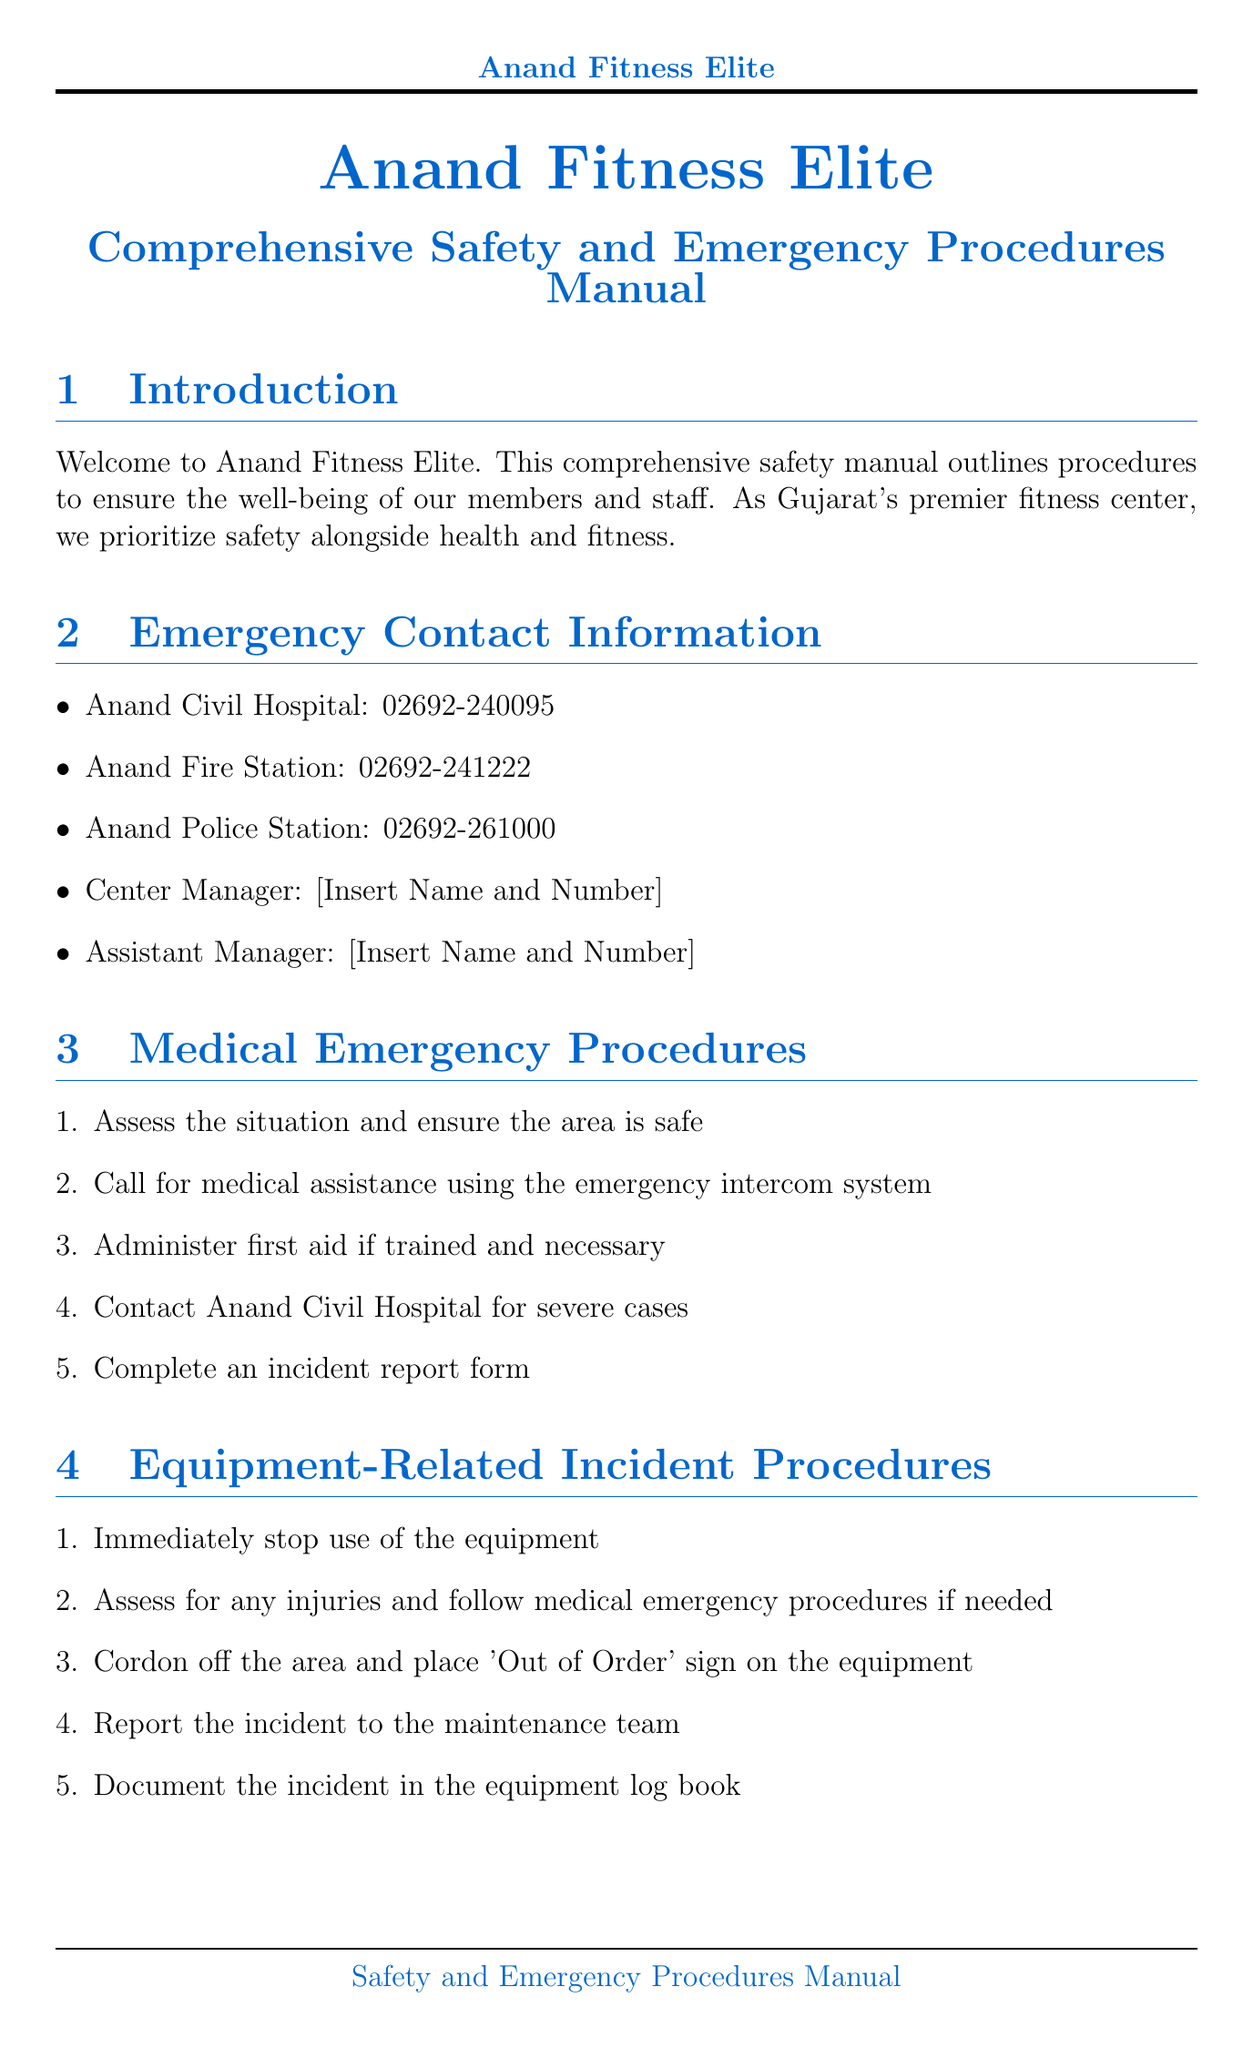What is the contact number for Anand Civil Hospital? The document lists the emergency contact number for Anand Civil Hospital under the "Emergency Contact Information" section.
Answer: 02692-240095 Where should members assemble during a fire evacuation? According to the "Fire Safety Protocols" section, members should assemble at the designated meeting point in the parking lot.
Answer: Parking lot What is the first step in medical emergency procedures? The "Medical Emergency Procedures" section outlines the first step as assessing the situation and ensuring the area is safe.
Answer: Assess the situation Where is the AED located? The document specifies the location of the AED in the "AED (Automated External Defibrillator) Location" section.
Answer: Main reception desk How often must staff renew their Basic First Aid and CPR certification? The "Staff Training Requirements" section mentions that Basic First Aid and CPR certification must be renewed annually.
Answer: Annually What must be done immediately after an equipment-related incident? The "Equipment-Related Incident Procedures" section advises that the first action should be to immediately stop use of the equipment.
Answer: Immediately stop use of the equipment What document must be submitted after an incident? The "Incident Reporting" section states that an incident report form must be submitted for all incidents.
Answer: Anand Fitness Elite Incident Report Form Which area is designated for first aid kits? The "First Aid Kit Locations" section lists multiple areas within the fitness center where first aid kits are available; therefore, any listed area can answer this question.
Answer: Main reception desk 